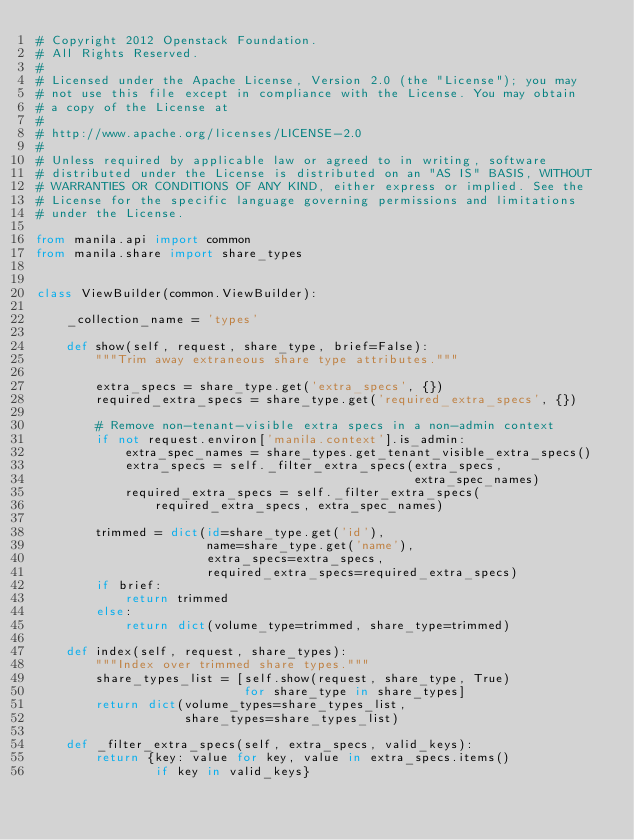Convert code to text. <code><loc_0><loc_0><loc_500><loc_500><_Python_># Copyright 2012 Openstack Foundation.
# All Rights Reserved.
#
# Licensed under the Apache License, Version 2.0 (the "License"); you may
# not use this file except in compliance with the License. You may obtain
# a copy of the License at
#
# http://www.apache.org/licenses/LICENSE-2.0
#
# Unless required by applicable law or agreed to in writing, software
# distributed under the License is distributed on an "AS IS" BASIS, WITHOUT
# WARRANTIES OR CONDITIONS OF ANY KIND, either express or implied. See the
# License for the specific language governing permissions and limitations
# under the License.

from manila.api import common
from manila.share import share_types


class ViewBuilder(common.ViewBuilder):

    _collection_name = 'types'

    def show(self, request, share_type, brief=False):
        """Trim away extraneous share type attributes."""

        extra_specs = share_type.get('extra_specs', {})
        required_extra_specs = share_type.get('required_extra_specs', {})

        # Remove non-tenant-visible extra specs in a non-admin context
        if not request.environ['manila.context'].is_admin:
            extra_spec_names = share_types.get_tenant_visible_extra_specs()
            extra_specs = self._filter_extra_specs(extra_specs,
                                                   extra_spec_names)
            required_extra_specs = self._filter_extra_specs(
                required_extra_specs, extra_spec_names)

        trimmed = dict(id=share_type.get('id'),
                       name=share_type.get('name'),
                       extra_specs=extra_specs,
                       required_extra_specs=required_extra_specs)
        if brief:
            return trimmed
        else:
            return dict(volume_type=trimmed, share_type=trimmed)

    def index(self, request, share_types):
        """Index over trimmed share types."""
        share_types_list = [self.show(request, share_type, True)
                            for share_type in share_types]
        return dict(volume_types=share_types_list,
                    share_types=share_types_list)

    def _filter_extra_specs(self, extra_specs, valid_keys):
        return {key: value for key, value in extra_specs.items()
                if key in valid_keys}
</code> 